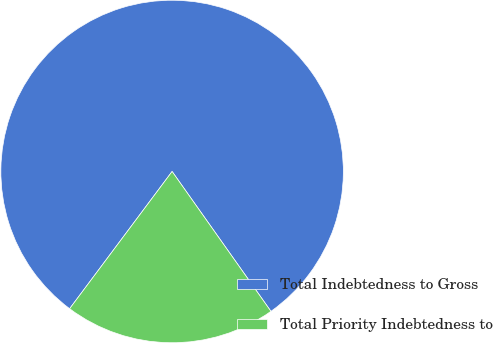Convert chart. <chart><loc_0><loc_0><loc_500><loc_500><pie_chart><fcel>Total Indebtedness to Gross<fcel>Total Priority Indebtedness to<nl><fcel>80.0%<fcel>20.0%<nl></chart> 